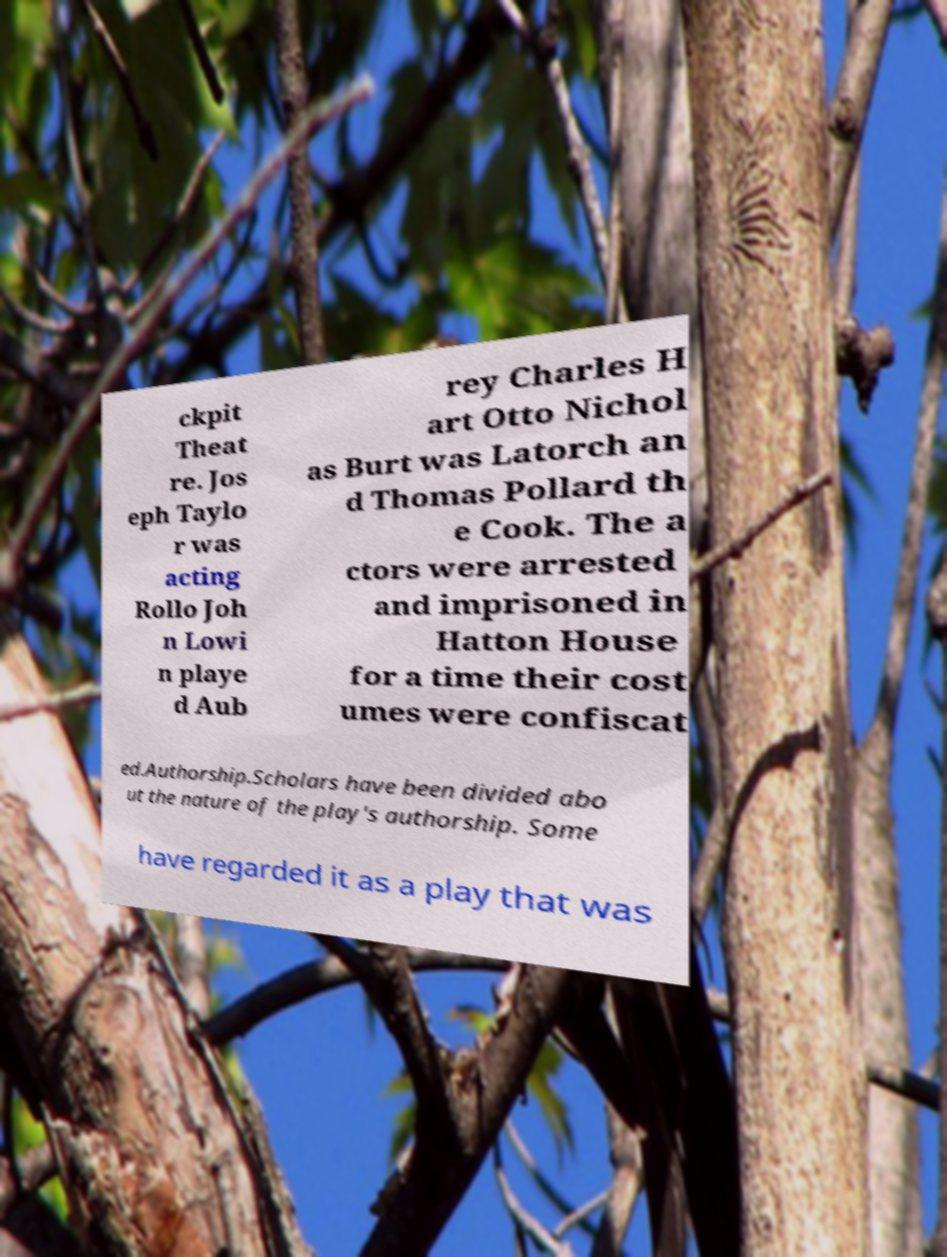For documentation purposes, I need the text within this image transcribed. Could you provide that? ckpit Theat re. Jos eph Taylo r was acting Rollo Joh n Lowi n playe d Aub rey Charles H art Otto Nichol as Burt was Latorch an d Thomas Pollard th e Cook. The a ctors were arrested and imprisoned in Hatton House for a time their cost umes were confiscat ed.Authorship.Scholars have been divided abo ut the nature of the play's authorship. Some have regarded it as a play that was 